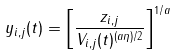<formula> <loc_0><loc_0><loc_500><loc_500>y _ { i , j } ( t ) = \left [ \frac { z _ { i , j } } { V _ { i , j } ( t ) ^ { ( a \eta ) / 2 } } \right ] ^ { 1 / a }</formula> 